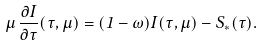<formula> <loc_0><loc_0><loc_500><loc_500>\mu \, \frac { \partial I } { \partial \tau } ( \tau , \mu ) = ( 1 - \omega ) I ( \tau , \mu ) - S _ { * } ( \tau ) .</formula> 